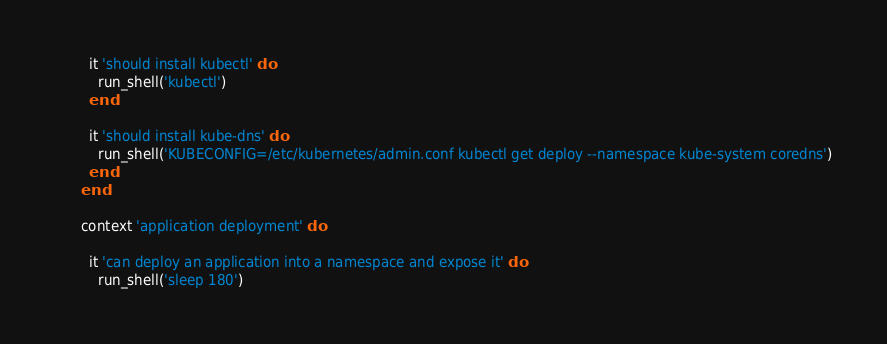<code> <loc_0><loc_0><loc_500><loc_500><_Ruby_>
        it 'should install kubectl' do
          run_shell('kubectl')
        end

        it 'should install kube-dns' do
          run_shell('KUBECONFIG=/etc/kubernetes/admin.conf kubectl get deploy --namespace kube-system coredns')
        end
      end

      context 'application deployment' do

        it 'can deploy an application into a namespace and expose it' do
          run_shell('sleep 180')</code> 